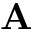Convert formula to latex. <formula><loc_0><loc_0><loc_500><loc_500>A</formula> 